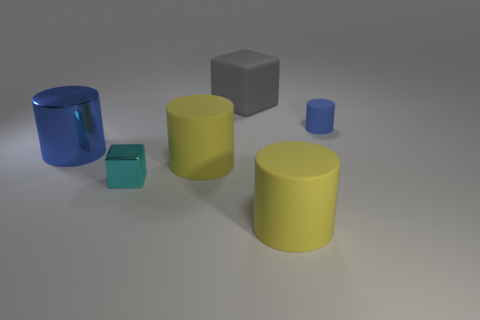Are there fewer purple objects than big shiny cylinders?
Offer a terse response. Yes. What shape is the blue object that is the same size as the cyan shiny thing?
Your response must be concise. Cylinder. What number of other things are the same color as the big shiny cylinder?
Give a very brief answer. 1. What number of tiny cyan things are there?
Your response must be concise. 1. How many matte objects are both left of the tiny blue matte cylinder and behind the tiny metallic thing?
Offer a terse response. 2. What is the tiny blue cylinder made of?
Provide a short and direct response. Rubber. Is there a tiny cube?
Offer a very short reply. Yes. There is a block that is in front of the big gray block; what is its color?
Provide a succinct answer. Cyan. How many big yellow cylinders are behind the big object that is in front of the small thing in front of the blue shiny object?
Your answer should be compact. 1. There is a cylinder that is both to the right of the large gray rubber thing and in front of the large blue cylinder; what material is it?
Offer a terse response. Rubber. 